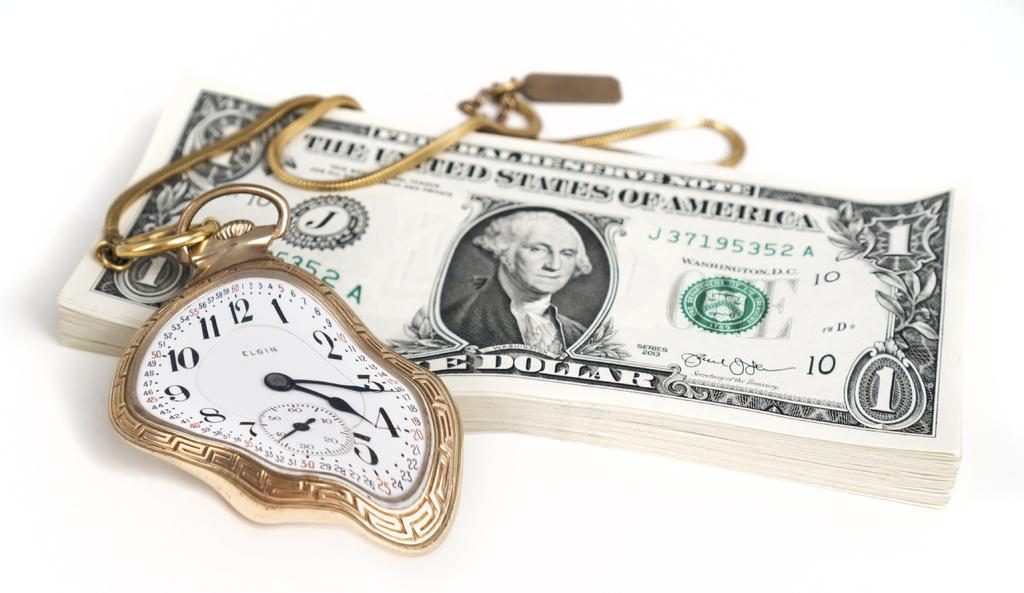<image>
Give a short and clear explanation of the subsequent image. Stack of money next to a stop watch which says ELGIN on it. 